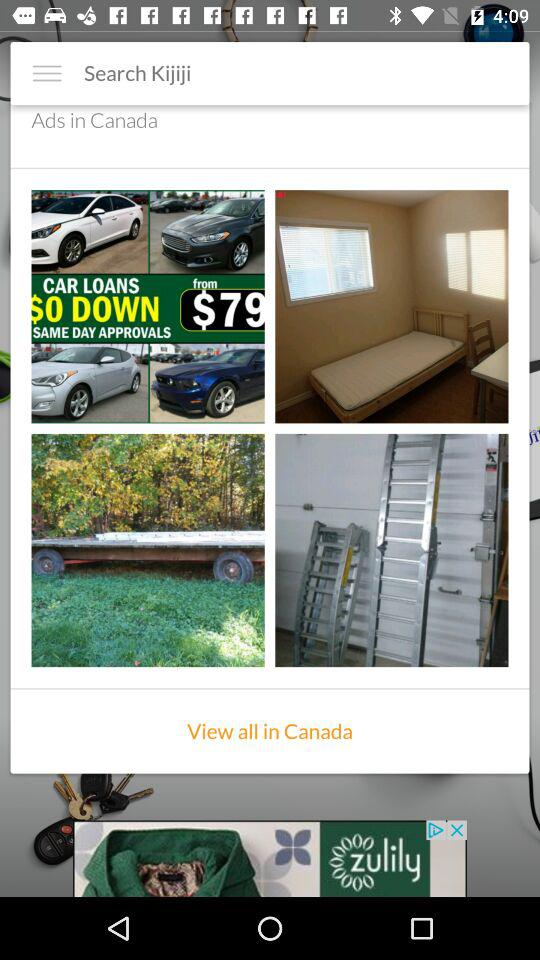What is the location? The location is Canada. 